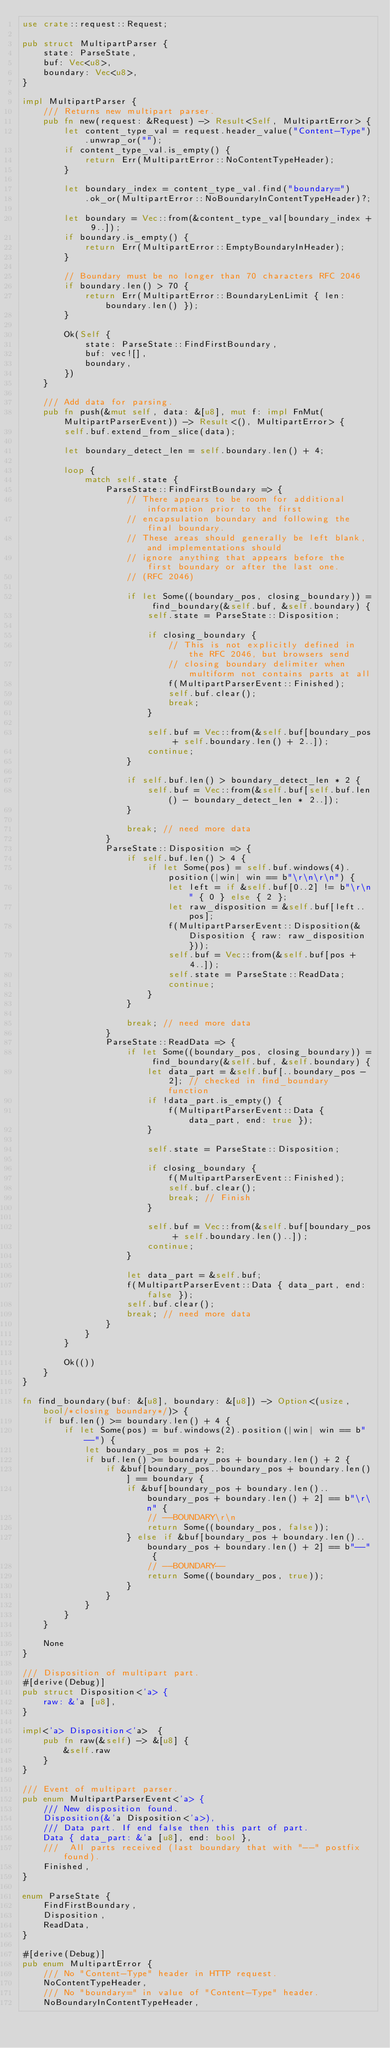Convert code to text. <code><loc_0><loc_0><loc_500><loc_500><_Rust_>use crate::request::Request;

pub struct MultipartParser {
    state: ParseState,
    buf: Vec<u8>,
    boundary: Vec<u8>,
}

impl MultipartParser {
    /// Returns new multipart parser.
    pub fn new(request: &Request) -> Result<Self, MultipartError> {
        let content_type_val = request.header_value("Content-Type").unwrap_or("");
        if content_type_val.is_empty() {
            return Err(MultipartError::NoContentTypeHeader);
        }

        let boundary_index = content_type_val.find("boundary=")
            .ok_or(MultipartError::NoBoundaryInContentTypeHeader)?;

        let boundary = Vec::from(&content_type_val[boundary_index + 9..]);
        if boundary.is_empty() {
            return Err(MultipartError::EmptyBoundaryInHeader);
        }

        // Boundary must be no longer than 70 characters RFC 2046
        if boundary.len() > 70 {
            return Err(MultipartError::BoundaryLenLimit { len: boundary.len() });
        }

        Ok(Self {
            state: ParseState::FindFirstBoundary,
            buf: vec![],
            boundary,
        })
    }

    /// Add data for parsing.
    pub fn push(&mut self, data: &[u8], mut f: impl FnMut(MultipartParserEvent)) -> Result<(), MultipartError> {
        self.buf.extend_from_slice(data);

        let boundary_detect_len = self.boundary.len() + 4;

        loop {
            match self.state {
                ParseState::FindFirstBoundary => {
                    // There appears to be room for additional information prior to the first
                    // encapsulation boundary and following the final boundary.
                    // These areas should generally be left blank, and implementations should
                    // ignore anything that appears before the first boundary or after the last one.
                    // (RFC 2046)

                    if let Some((boundary_pos, closing_boundary)) = find_boundary(&self.buf, &self.boundary) {
                        self.state = ParseState::Disposition;

                        if closing_boundary {
                            // This is not explicitly defined in the RFC 2046, but browsers send
                            // closing boundary delimiter when multiform not contains parts at all
                            f(MultipartParserEvent::Finished);
                            self.buf.clear();
                            break;
                        }

                        self.buf = Vec::from(&self.buf[boundary_pos + self.boundary.len() + 2..]);
                        continue;
                    }

                    if self.buf.len() > boundary_detect_len * 2 {
                        self.buf = Vec::from(&self.buf[self.buf.len() - boundary_detect_len * 2..]);
                    }

                    break; // need more data
                }
                ParseState::Disposition => {
                    if self.buf.len() > 4 {
                        if let Some(pos) = self.buf.windows(4).position(|win| win == b"\r\n\r\n") {
                            let left = if &self.buf[0..2] != b"\r\n" { 0 } else { 2 };
                            let raw_disposition = &self.buf[left..pos];
                            f(MultipartParserEvent::Disposition(&Disposition { raw: raw_disposition }));
                            self.buf = Vec::from(&self.buf[pos + 4..]);
                            self.state = ParseState::ReadData;
                            continue;
                        }
                    }

                    break; // need more data
                }
                ParseState::ReadData => {
                    if let Some((boundary_pos, closing_boundary)) = find_boundary(&self.buf, &self.boundary) {
                        let data_part = &self.buf[..boundary_pos - 2]; // checked in find_boundary function
                        if !data_part.is_empty() {
                            f(MultipartParserEvent::Data { data_part, end: true });
                        }

                        self.state = ParseState::Disposition;

                        if closing_boundary {
                            f(MultipartParserEvent::Finished);
                            self.buf.clear();
                            break; // Finish
                        }

                        self.buf = Vec::from(&self.buf[boundary_pos + self.boundary.len()..]);
                        continue;
                    }

                    let data_part = &self.buf;
                    f(MultipartParserEvent::Data { data_part, end: false });
                    self.buf.clear();
                    break; // need more data
                }
            }
        }

        Ok(())
    }
}

fn find_boundary(buf: &[u8], boundary: &[u8]) -> Option<(usize, bool/*closing boundary*/)> {
    if buf.len() >= boundary.len() + 4 {
        if let Some(pos) = buf.windows(2).position(|win| win == b"--") {
            let boundary_pos = pos + 2;
            if buf.len() >= boundary_pos + boundary.len() + 2 {
                if &buf[boundary_pos..boundary_pos + boundary.len()] == boundary {
                    if &buf[boundary_pos + boundary.len()..boundary_pos + boundary.len() + 2] == b"\r\n" {
                        // --BOUNDARY\r\n
                        return Some((boundary_pos, false));
                    } else if &buf[boundary_pos + boundary.len()..boundary_pos + boundary.len() + 2] == b"--" {
                        // --BOUNDARY--
                        return Some((boundary_pos, true));
                    }
                }
            }
        }
    }

    None
}

/// Disposition of multipart part.
#[derive(Debug)]
pub struct Disposition<'a> {
    raw: &'a [u8],
}

impl<'a> Disposition<'a>  {
    pub fn raw(&self) -> &[u8] {
        &self.raw
    }
}

/// Event of multipart parser.
pub enum MultipartParserEvent<'a> {
    /// New disposition found.
    Disposition(&'a Disposition<'a>),
    /// Data part. If end false then this part of part.
    Data { data_part: &'a [u8], end: bool },
    ///  All parts received (last boundary that with "--" postfix found).
    Finished,
}

enum ParseState {
    FindFirstBoundary,
    Disposition,
    ReadData,
}

#[derive(Debug)]
pub enum MultipartError {
    /// No "Content-Type" header in HTTP request.
    NoContentTypeHeader,
    /// No "boundary=" in value of "Content-Type" header.
    NoBoundaryInContentTypeHeader,</code> 